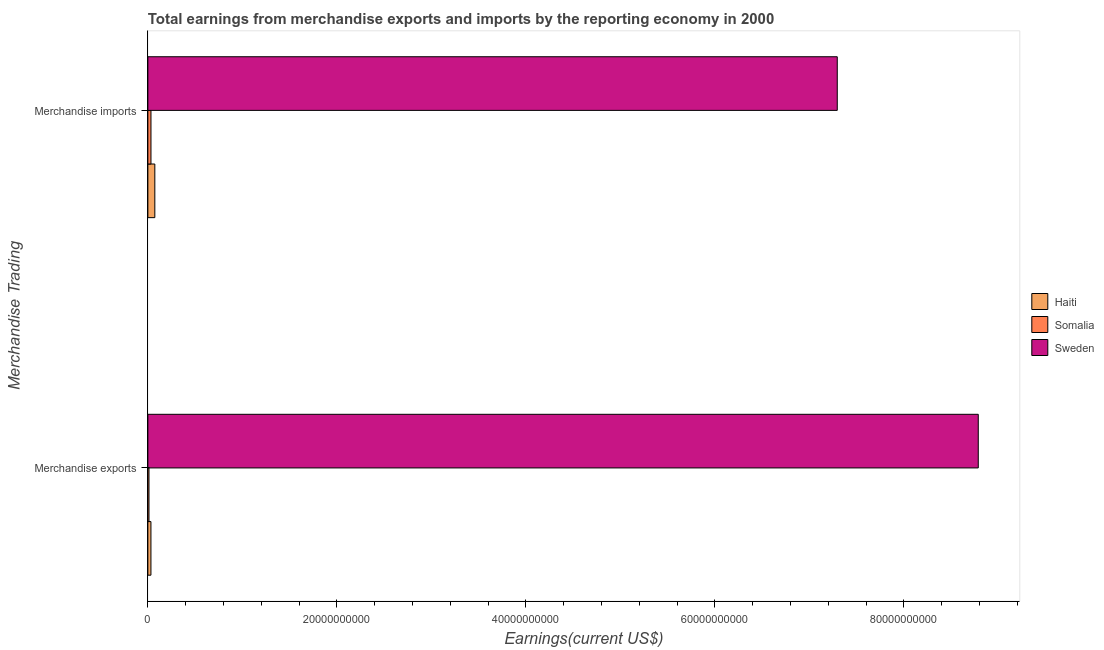How many bars are there on the 1st tick from the top?
Make the answer very short. 3. How many bars are there on the 1st tick from the bottom?
Keep it short and to the point. 3. What is the label of the 2nd group of bars from the top?
Your answer should be very brief. Merchandise exports. What is the earnings from merchandise exports in Somalia?
Your answer should be compact. 1.18e+08. Across all countries, what is the maximum earnings from merchandise imports?
Provide a succinct answer. 7.30e+1. Across all countries, what is the minimum earnings from merchandise exports?
Give a very brief answer. 1.18e+08. In which country was the earnings from merchandise imports maximum?
Make the answer very short. Sweden. In which country was the earnings from merchandise exports minimum?
Keep it short and to the point. Somalia. What is the total earnings from merchandise imports in the graph?
Provide a short and direct response. 7.40e+1. What is the difference between the earnings from merchandise imports in Sweden and that in Somalia?
Ensure brevity in your answer.  7.26e+1. What is the difference between the earnings from merchandise exports in Sweden and the earnings from merchandise imports in Haiti?
Ensure brevity in your answer.  8.71e+1. What is the average earnings from merchandise imports per country?
Ensure brevity in your answer.  2.47e+1. What is the difference between the earnings from merchandise exports and earnings from merchandise imports in Haiti?
Ensure brevity in your answer.  -4.12e+08. What is the ratio of the earnings from merchandise imports in Haiti to that in Somalia?
Your answer should be very brief. 2.24. Is the earnings from merchandise imports in Somalia less than that in Sweden?
Offer a terse response. Yes. In how many countries, is the earnings from merchandise exports greater than the average earnings from merchandise exports taken over all countries?
Give a very brief answer. 1. What does the 3rd bar from the top in Merchandise exports represents?
Offer a terse response. Haiti. What does the 2nd bar from the bottom in Merchandise imports represents?
Your answer should be very brief. Somalia. How many bars are there?
Your answer should be compact. 6. How many countries are there in the graph?
Offer a very short reply. 3. What is the difference between two consecutive major ticks on the X-axis?
Your answer should be very brief. 2.00e+1. Are the values on the major ticks of X-axis written in scientific E-notation?
Keep it short and to the point. No. Does the graph contain any zero values?
Offer a very short reply. No. Does the graph contain grids?
Give a very brief answer. No. Where does the legend appear in the graph?
Keep it short and to the point. Center right. How are the legend labels stacked?
Your response must be concise. Vertical. What is the title of the graph?
Ensure brevity in your answer.  Total earnings from merchandise exports and imports by the reporting economy in 2000. Does "Guyana" appear as one of the legend labels in the graph?
Keep it short and to the point. No. What is the label or title of the X-axis?
Provide a short and direct response. Earnings(current US$). What is the label or title of the Y-axis?
Your answer should be compact. Merchandise Trading. What is the Earnings(current US$) of Haiti in Merchandise exports?
Ensure brevity in your answer.  3.24e+08. What is the Earnings(current US$) in Somalia in Merchandise exports?
Ensure brevity in your answer.  1.18e+08. What is the Earnings(current US$) of Sweden in Merchandise exports?
Offer a terse response. 8.79e+1. What is the Earnings(current US$) in Haiti in Merchandise imports?
Give a very brief answer. 7.37e+08. What is the Earnings(current US$) in Somalia in Merchandise imports?
Ensure brevity in your answer.  3.29e+08. What is the Earnings(current US$) of Sweden in Merchandise imports?
Your response must be concise. 7.30e+1. Across all Merchandise Trading, what is the maximum Earnings(current US$) of Haiti?
Keep it short and to the point. 7.37e+08. Across all Merchandise Trading, what is the maximum Earnings(current US$) in Somalia?
Provide a succinct answer. 3.29e+08. Across all Merchandise Trading, what is the maximum Earnings(current US$) in Sweden?
Your answer should be very brief. 8.79e+1. Across all Merchandise Trading, what is the minimum Earnings(current US$) in Haiti?
Give a very brief answer. 3.24e+08. Across all Merchandise Trading, what is the minimum Earnings(current US$) of Somalia?
Your response must be concise. 1.18e+08. Across all Merchandise Trading, what is the minimum Earnings(current US$) in Sweden?
Offer a terse response. 7.30e+1. What is the total Earnings(current US$) in Haiti in the graph?
Provide a succinct answer. 1.06e+09. What is the total Earnings(current US$) in Somalia in the graph?
Offer a terse response. 4.46e+08. What is the total Earnings(current US$) of Sweden in the graph?
Your answer should be compact. 1.61e+11. What is the difference between the Earnings(current US$) of Haiti in Merchandise exports and that in Merchandise imports?
Your answer should be very brief. -4.12e+08. What is the difference between the Earnings(current US$) in Somalia in Merchandise exports and that in Merchandise imports?
Give a very brief answer. -2.11e+08. What is the difference between the Earnings(current US$) of Sweden in Merchandise exports and that in Merchandise imports?
Offer a terse response. 1.49e+1. What is the difference between the Earnings(current US$) in Haiti in Merchandise exports and the Earnings(current US$) in Somalia in Merchandise imports?
Offer a very short reply. -4.27e+06. What is the difference between the Earnings(current US$) of Haiti in Merchandise exports and the Earnings(current US$) of Sweden in Merchandise imports?
Your response must be concise. -7.26e+1. What is the difference between the Earnings(current US$) of Somalia in Merchandise exports and the Earnings(current US$) of Sweden in Merchandise imports?
Your response must be concise. -7.28e+1. What is the average Earnings(current US$) of Haiti per Merchandise Trading?
Provide a short and direct response. 5.31e+08. What is the average Earnings(current US$) in Somalia per Merchandise Trading?
Keep it short and to the point. 2.23e+08. What is the average Earnings(current US$) of Sweden per Merchandise Trading?
Your response must be concise. 8.04e+1. What is the difference between the Earnings(current US$) of Haiti and Earnings(current US$) of Somalia in Merchandise exports?
Your answer should be compact. 2.07e+08. What is the difference between the Earnings(current US$) in Haiti and Earnings(current US$) in Sweden in Merchandise exports?
Keep it short and to the point. -8.76e+1. What is the difference between the Earnings(current US$) of Somalia and Earnings(current US$) of Sweden in Merchandise exports?
Ensure brevity in your answer.  -8.78e+1. What is the difference between the Earnings(current US$) in Haiti and Earnings(current US$) in Somalia in Merchandise imports?
Provide a succinct answer. 4.08e+08. What is the difference between the Earnings(current US$) in Haiti and Earnings(current US$) in Sweden in Merchandise imports?
Provide a short and direct response. -7.22e+1. What is the difference between the Earnings(current US$) in Somalia and Earnings(current US$) in Sweden in Merchandise imports?
Offer a terse response. -7.26e+1. What is the ratio of the Earnings(current US$) in Haiti in Merchandise exports to that in Merchandise imports?
Offer a terse response. 0.44. What is the ratio of the Earnings(current US$) of Somalia in Merchandise exports to that in Merchandise imports?
Provide a succinct answer. 0.36. What is the ratio of the Earnings(current US$) of Sweden in Merchandise exports to that in Merchandise imports?
Make the answer very short. 1.2. What is the difference between the highest and the second highest Earnings(current US$) of Haiti?
Offer a very short reply. 4.12e+08. What is the difference between the highest and the second highest Earnings(current US$) in Somalia?
Your answer should be compact. 2.11e+08. What is the difference between the highest and the second highest Earnings(current US$) of Sweden?
Your response must be concise. 1.49e+1. What is the difference between the highest and the lowest Earnings(current US$) of Haiti?
Provide a short and direct response. 4.12e+08. What is the difference between the highest and the lowest Earnings(current US$) of Somalia?
Your answer should be compact. 2.11e+08. What is the difference between the highest and the lowest Earnings(current US$) in Sweden?
Offer a very short reply. 1.49e+1. 